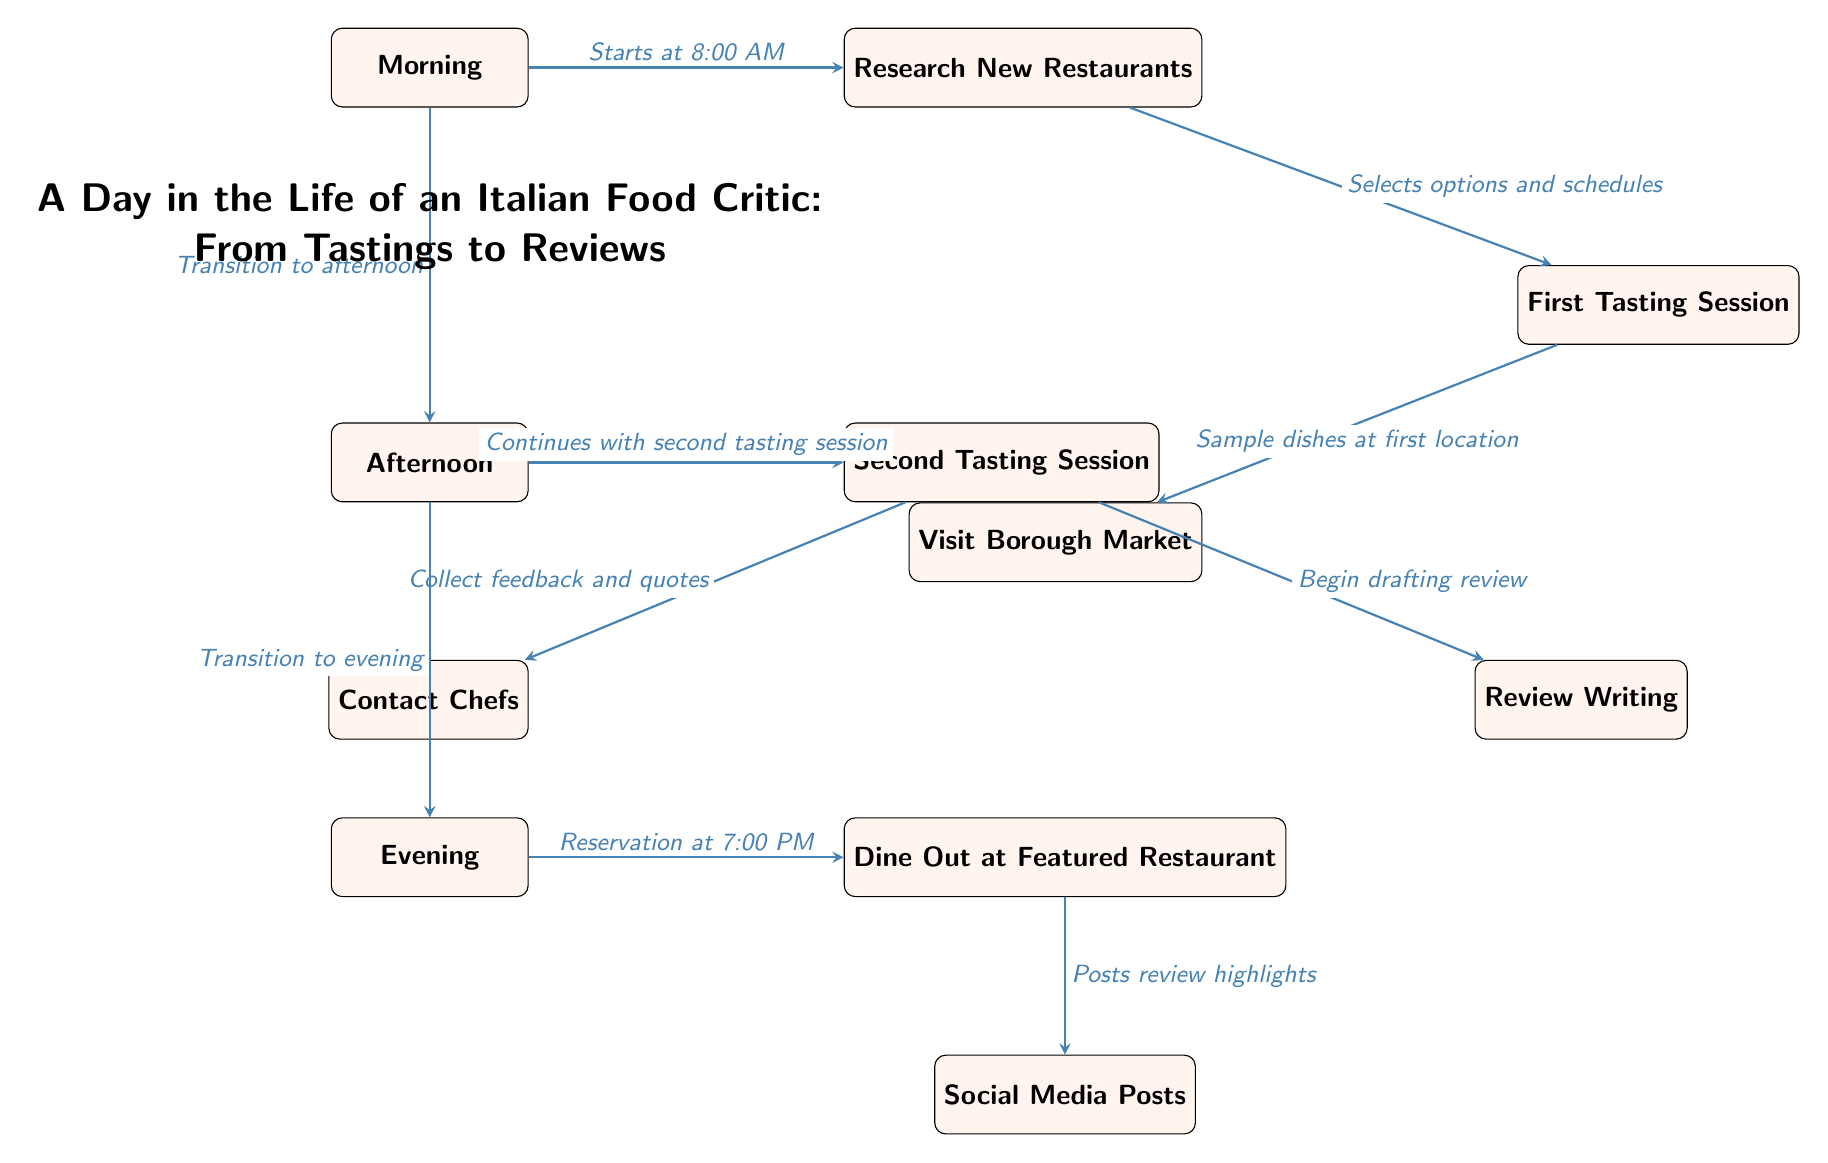What time does the day start for the food critic? The diagram indicates that the critic's day starts at 8:00 AM, as shown next to the arrow pointing from the Morning node to the Research New Restaurants node.
Answer: 8:00 AM How many main sections are represented in the diagram? The diagram consists of three main sections: Morning, Afternoon, and Evening, as visually differentiated by the layout and spacing of the nodes.
Answer: 3 What activity follows the first tasting session? According to the diagram, the first tasting session is followed by either a visit to Borough Market or a transition to the afternoon. The arrow leading from the first tasting session indicates a connection to the visit to Borough Market.
Answer: Visit Borough Market What time reservation is indicated for dining out? The diagram specifies that the reservation for dining out is at 7:00 PM, which is illustrated next to the arrow leading from the Evening node to the Dine Out at Featured Restaurant node.
Answer: 7:00 PM What does the critic do after dining out? After dining out, the food critic posts review highlights on social media, as indicated by the arrow leading from the Dine Out node to the Social Media Posts node.
Answer: Social Media Posts What is the purpose of the second tasting session? The second tasting session leads to two outcomes: beginning the review writing and collecting feedback and quotes from chefs, as illustrated by the branching arrows after the Second Tasting Session node. This reflects the dual purpose of gathering impressions and preparing the review.
Answer: Begin drafting review What essential action occurs in the morning before the first tasting session? Before the first tasting session, the critic conducts research on new restaurants, as this is the first step depicted in the morning section and is connected directly to the first tasting session.
Answer: Research New Restaurants What does contacting chefs relate to in the afternoon section? Contacting chefs in the afternoon section is related to the second tasting session, showing a connection where the critic collects feedback and quotes from chefs after the second tasting. This interlinks the tasting experience with the review preparation.
Answer: Collect feedback and quotes 